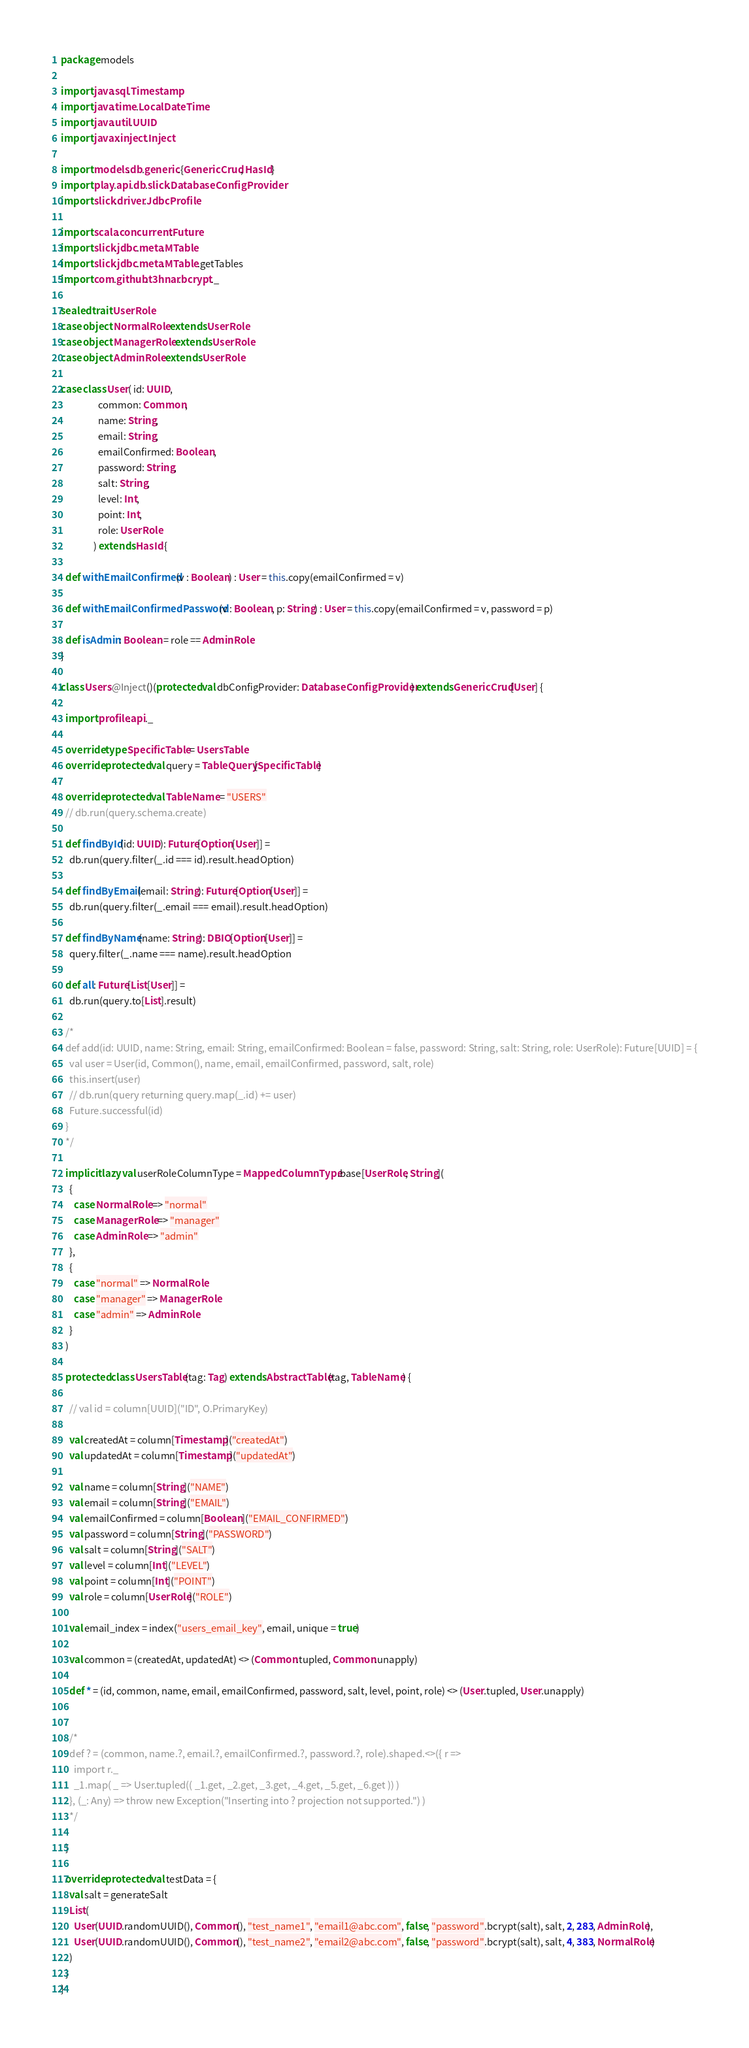Convert code to text. <code><loc_0><loc_0><loc_500><loc_500><_Scala_>package models

import java.sql.Timestamp
import java.time.LocalDateTime
import java.util.UUID
import javax.inject.Inject

import models.db.generic.{GenericCrud, HasId}
import play.api.db.slick.DatabaseConfigProvider
import slick.driver.JdbcProfile

import scala.concurrent.Future
import slick.jdbc.meta.MTable
import slick.jdbc.meta.MTable.getTables
import com.github.t3hnar.bcrypt._

sealed trait UserRole
case object NormalRole extends UserRole
case object ManagerRole extends UserRole
case object AdminRole extends UserRole

case class User( id: UUID,
                 common: Common,
                 name: String,
                 email: String,
                 emailConfirmed: Boolean,
                 password: String,
                 salt: String,
                 level: Int,
                 point: Int,
                 role: UserRole
               ) extends HasId {

  def withEmailConfirmed(v : Boolean) : User = this.copy(emailConfirmed = v)

  def withEmailConfirmedPassword(v : Boolean, p: String) : User = this.copy(emailConfirmed = v, password = p)

  def isAdmin: Boolean = role == AdminRole
}

class Users @Inject()(protected val dbConfigProvider: DatabaseConfigProvider) extends GenericCrud[User] {

  import profile.api._

  override type SpecificTable = UsersTable
  override protected val query = TableQuery[SpecificTable]

  override protected val TableName = "USERS"
  // db.run(query.schema.create)

  def findById(id: UUID): Future[Option[User]] =
    db.run(query.filter(_.id === id).result.headOption)

  def findByEmail(email: String): Future[Option[User]] =
    db.run(query.filter(_.email === email).result.headOption)

  def findByName(name: String): DBIO[Option[User]] =
    query.filter(_.name === name).result.headOption

  def all: Future[List[User]] =
    db.run(query.to[List].result)

  /*
  def add(id: UUID, name: String, email: String, emailConfirmed: Boolean = false, password: String, salt: String, role: UserRole): Future[UUID] = {
    val user = User(id, Common(), name, email, emailConfirmed, password, salt, role)
    this.insert(user)
    // db.run(query returning query.map(_.id) += user)
    Future.successful(id)
  }
  */

  implicit lazy val userRoleColumnType = MappedColumnType.base[UserRole, String](
    {
      case NormalRole => "normal"
      case ManagerRole => "manager"
      case AdminRole => "admin"
    },
    {
      case "normal" => NormalRole
      case "manager" => ManagerRole
      case "admin" => AdminRole
    }
  )

  protected class UsersTable(tag: Tag) extends AbstractTable(tag, TableName) {

    // val id = column[UUID]("ID", O.PrimaryKey)

    val createdAt = column[Timestamp]("createdAt")
    val updatedAt = column[Timestamp]("updatedAt")

    val name = column[String]("NAME")
    val email = column[String]("EMAIL")
    val emailConfirmed = column[Boolean]("EMAIL_CONFIRMED")
    val password = column[String]("PASSWORD")
    val salt = column[String]("SALT")
    val level = column[Int]("LEVEL")
    val point = column[Int]("POINT")
    val role = column[UserRole]("ROLE")

    val email_index = index("users_email_key", email, unique = true)

    val common = (createdAt, updatedAt) <> (Common.tupled, Common.unapply)

    def * = (id, common, name, email, emailConfirmed, password, salt, level, point, role) <> (User.tupled, User.unapply)


    /*
    def ? = (common, name.?, email.?, emailConfirmed.?, password.?, role).shaped.<>({ r =>
      import r._
      _1.map( _ => User.tupled(( _1.get, _2.get, _3.get, _4.get, _5.get, _6.get )) )
    }, (_: Any) => throw new Exception("Inserting into ? projection not supported.") )
    */

  }

  override protected val testData = {
    val salt = generateSalt
    List(
      User(UUID.randomUUID(), Common(), "test_name1", "email1@abc.com", false, "password".bcrypt(salt), salt, 2, 283, AdminRole),
      User(UUID.randomUUID(), Common(), "test_name2", "email2@abc.com", false, "password".bcrypt(salt), salt, 4, 383, NormalRole)
    )
  }
}
</code> 